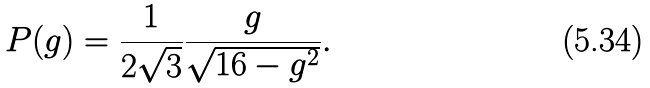Convert formula to latex. <formula><loc_0><loc_0><loc_500><loc_500>P ( g ) = \frac { 1 } { 2 \sqrt { 3 } } \frac { g } { \sqrt { 1 6 - g ^ { 2 } } } .</formula> 